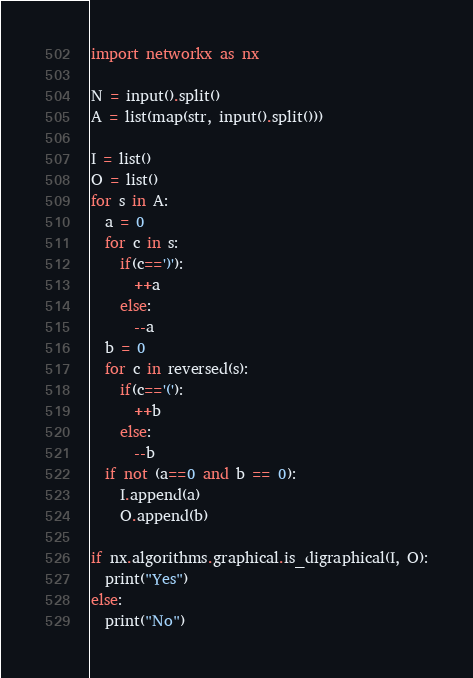Convert code to text. <code><loc_0><loc_0><loc_500><loc_500><_Python_>import networkx as nx

N = input().split()
A = list(map(str, input().split()))

I = list()
O = list()
for s in A:
  a = 0
  for c in s:
    if(c==')'):
      ++a
    else:
      --a
  b = 0
  for c in reversed(s):
    if(c=='('):
      ++b
    else:
      --b
  if not (a==0 and b == 0):
    I.append(a)
    O.append(b)

if nx.algorithms.graphical.is_digraphical(I, O):
  print("Yes")
else:
  print("No")</code> 